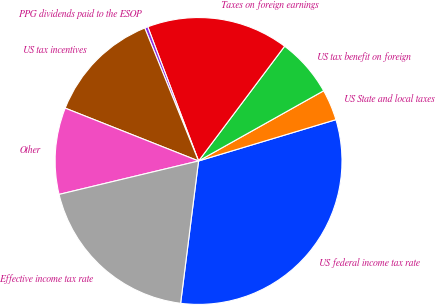<chart> <loc_0><loc_0><loc_500><loc_500><pie_chart><fcel>US federal income tax rate<fcel>US State and local taxes<fcel>US tax benefit on foreign<fcel>Taxes on foreign earnings<fcel>PPG dividends paid to the ESOP<fcel>US tax incentives<fcel>Other<fcel>Effective income tax rate<nl><fcel>31.65%<fcel>3.49%<fcel>6.62%<fcel>16.0%<fcel>0.36%<fcel>12.88%<fcel>9.75%<fcel>19.26%<nl></chart> 